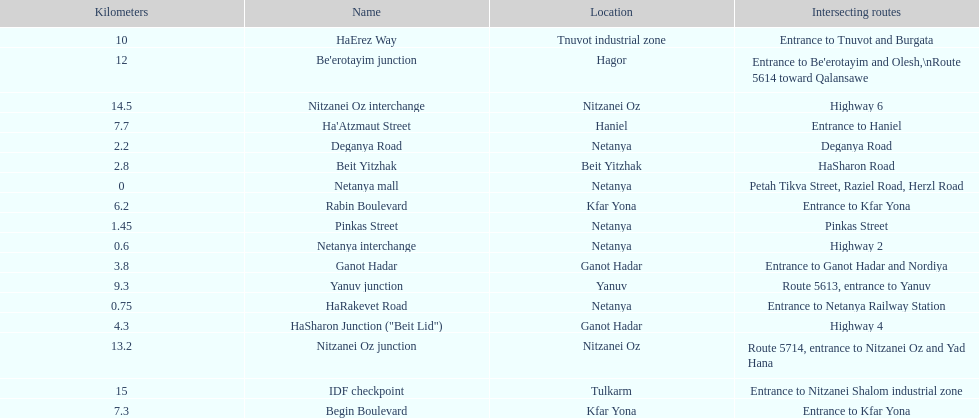After you finish deganya road, what part comes subsequently? Beit Yitzhak. 